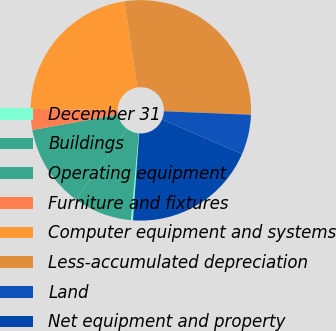Convert chart. <chart><loc_0><loc_0><loc_500><loc_500><pie_chart><fcel>December 31<fcel>Buildings<fcel>Operating equipment<fcel>Furniture and fixtures<fcel>Computer equipment and systems<fcel>Less-accumulated depreciation<fcel>Land<fcel>Net equipment and property<nl><fcel>0.3%<fcel>8.61%<fcel>12.1%<fcel>3.07%<fcel>22.42%<fcel>28.01%<fcel>5.84%<fcel>19.65%<nl></chart> 